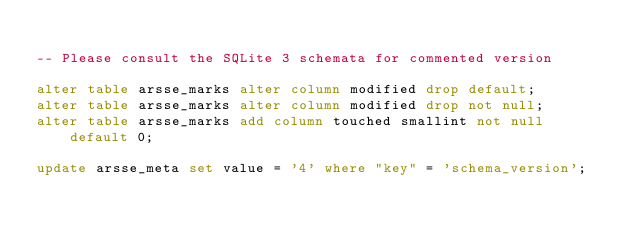Convert code to text. <code><loc_0><loc_0><loc_500><loc_500><_SQL_>
-- Please consult the SQLite 3 schemata for commented version

alter table arsse_marks alter column modified drop default;
alter table arsse_marks alter column modified drop not null;
alter table arsse_marks add column touched smallint not null default 0;

update arsse_meta set value = '4' where "key" = 'schema_version';
</code> 